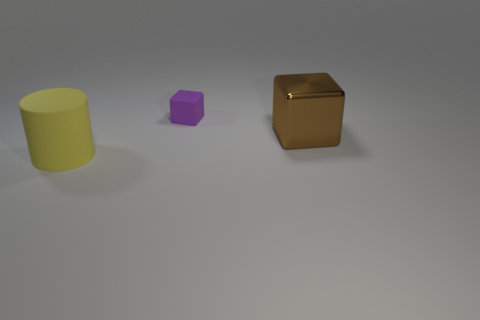Is there anything else that has the same material as the big brown thing?
Ensure brevity in your answer.  No. Is the number of small cubes on the left side of the small thing less than the number of small purple objects?
Keep it short and to the point. Yes. Is the color of the matte cylinder the same as the metal thing?
Ensure brevity in your answer.  No. The metallic thing has what size?
Provide a short and direct response. Large. How many other matte blocks have the same color as the rubber cube?
Provide a short and direct response. 0. There is a rubber object in front of the matte thing behind the large cube; are there any yellow objects in front of it?
Give a very brief answer. No. There is a yellow rubber object that is the same size as the brown block; what is its shape?
Give a very brief answer. Cylinder. How many small objects are purple things or blue cylinders?
Your answer should be compact. 1. There is a object that is the same material as the tiny purple block; what is its color?
Ensure brevity in your answer.  Yellow. Is the shape of the thing on the right side of the tiny purple cube the same as the rubber object on the right side of the big yellow cylinder?
Make the answer very short. Yes. 